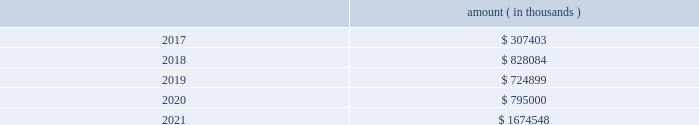Entergy corporation and subsidiaries notes to financial statements ( a ) consists of pollution control revenue bonds and environmental revenue bonds , some of which are secured by collateral first mortgage bonds .
( b ) these notes do not have a stated interest rate , but have an implicit interest rate of 4.8% ( 4.8 % ) .
( c ) pursuant to the nuclear waste policy act of 1982 , entergy 2019s nuclear owner/licensee subsidiaries have contracts with the doe for spent nuclear fuel disposal service .
The contracts include a one-time fee for generation prior to april 7 , 1983 .
Entergy arkansas is the only entergy company that generated electric power with nuclear fuel prior to that date and includes the one-time fee , plus accrued interest , in long-term debt .
( d ) see note 10 to the financial statements for further discussion of the waterford 3 lease obligation and entergy louisiana 2019s acquisition of the equity participant 2019s beneficial interest in the waterford 3 leased assets and for further discussion of the grand gulf lease obligation .
( e ) this note does not have a stated interest rate , but has an implicit interest rate of 7.458% ( 7.458 % ) .
( f ) the fair value excludes lease obligations of $ 57 million at entergy louisiana and $ 34 million at system energy , and long-term doe obligations of $ 182 million at entergy arkansas , and includes debt due within one year .
Fair values are classified as level 2 in the fair value hierarchy discussed in note 15 to the financial statements and are based on prices derived from inputs such as benchmark yields and reported trades .
The annual long-term debt maturities ( excluding lease obligations and long-term doe obligations ) for debt outstanding as of december 31 , 2016 , for the next five years are as follows : amount ( in thousands ) .
In november 2000 , entergy 2019s non-utility nuclear business purchased the fitzpatrick and indian point 3 power plants in a seller-financed transaction .
As part of the purchase agreement with nypa , entergy recorded a liability representing the net present value of the payments entergy would be liable to nypa for each year that the fitzpatrick and indian point 3 power plants would run beyond their respective original nrc license expiration date .
In october 2015 , entergy announced a planned shutdown of fitzpatrick at the end of its fuel cycle .
As a result of the announcement , entergy reduced this liability by $ 26.4 million pursuant to the terms of the purchase agreement .
In august 2016 , entergy entered into a trust transfer agreement with nypa to transfer the decommissioning trust funds and decommissioning liabilities for the indian point 3 and fitzpatrick plants to entergy .
As part of the trust transfer agreement , the original decommissioning agreements were amended , and the entergy subsidiaries 2019 obligation to make additional license extension payments to nypa was eliminated .
In the third quarter 2016 , entergy removed the note payable of $ 35.1 million from the consolidated balance sheet .
Entergy louisiana , entergy mississippi , entergy texas , and system energy have obtained long-term financing authorizations from the ferc that extend through october 2017 .
Entergy arkansas has obtained long-term financing authorization from the apsc that extends through december 2018 .
Entergy new orleans has obtained long-term financing authorization from the city council that extends through june 2018 .
Capital funds agreement pursuant to an agreement with certain creditors , entergy corporation has agreed to supply system energy with sufficient capital to : 2022 maintain system energy 2019s equity capital at a minimum of 35% ( 35 % ) of its total capitalization ( excluding short- term debt ) ; .
What are long term debt payments in the next three years , in thousands?\\n? 
Computations: ((307403 + 828084) + 724899)
Answer: 1860386.0. 